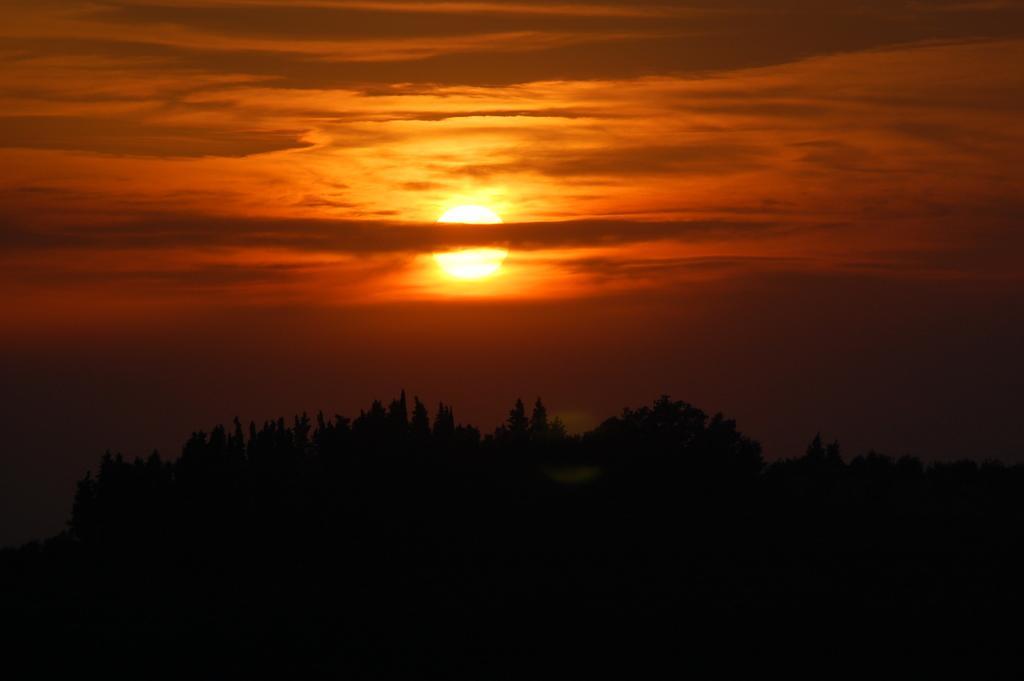Describe this image in one or two sentences. In the image in the center we can see the sky,clouds,sun,trees etc. 